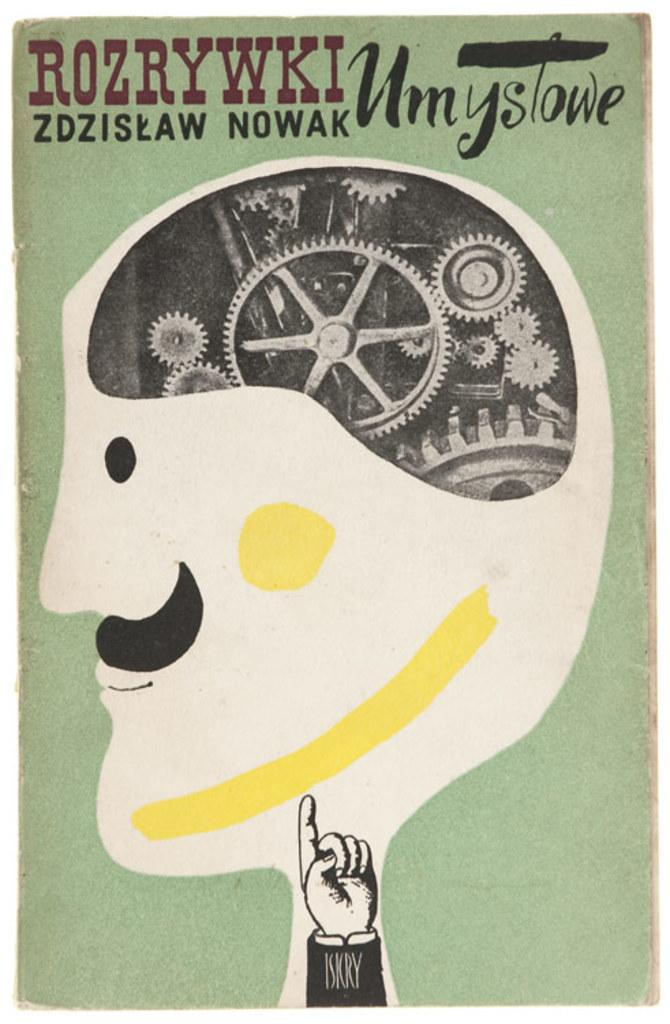<image>
Provide a brief description of the given image. A poster of a man with gears inside his head with a hand that says Isicry pointing to the head. 